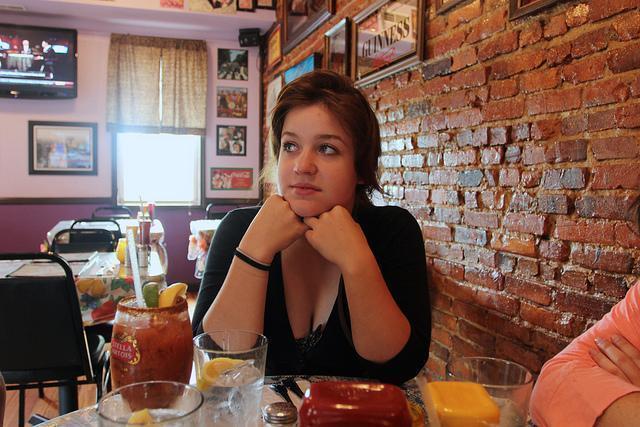What is held in the red and yellow containers on the table?
Indicate the correct response by choosing from the four available options to answer the question.
Options: Lettuce, eggs, condiments, salad dressing. Condiments. 